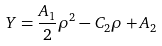Convert formula to latex. <formula><loc_0><loc_0><loc_500><loc_500>Y = \frac { A _ { 1 } } { 2 } \rho ^ { 2 } - C _ { 2 } \rho + A _ { 2 }</formula> 